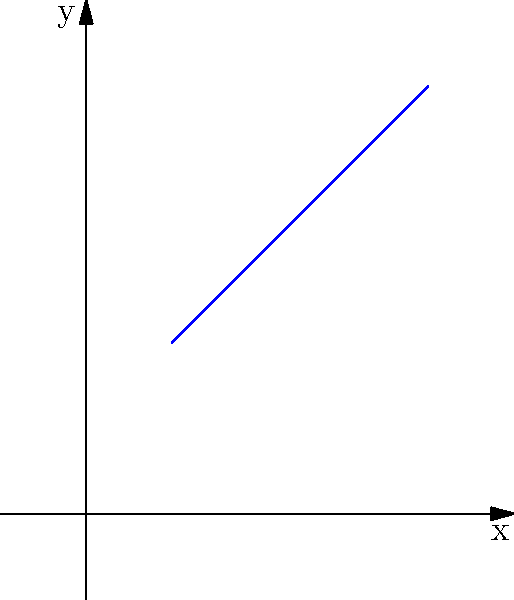Given two points A(1, 2) and B(4, 5) on a 2D plot, find the equation of the line passing through these points in slope-intercept form (y = mx + b). Round the slope and y-intercept to two decimal places if necessary. To find the equation of the line passing through two points, we'll follow these steps:

1. Calculate the slope (m) using the slope formula:
   $$m = \frac{y_2 - y_1}{x_2 - x_1} = \frac{5 - 2}{4 - 1} = \frac{3}{3} = 1$$

2. Use the point-slope form of a line equation:
   $$y - y_1 = m(x - x_1)$$

3. Substitute the slope and coordinates of point A(1, 2):
   $$y - 2 = 1(x - 1)$$

4. Simplify and rearrange to get the slope-intercept form (y = mx + b):
   $$y - 2 = x - 1$$
   $$y = x - 1 + 2$$
   $$y = x + 1$$

5. Verify the equation passes through point B(4, 5):
   $$5 = 4 + 1$$
   $$5 = 5$$ (equation verified)

Therefore, the equation of the line in slope-intercept form is y = x + 1, where m = 1 and b = 1.
Answer: y = x + 1 